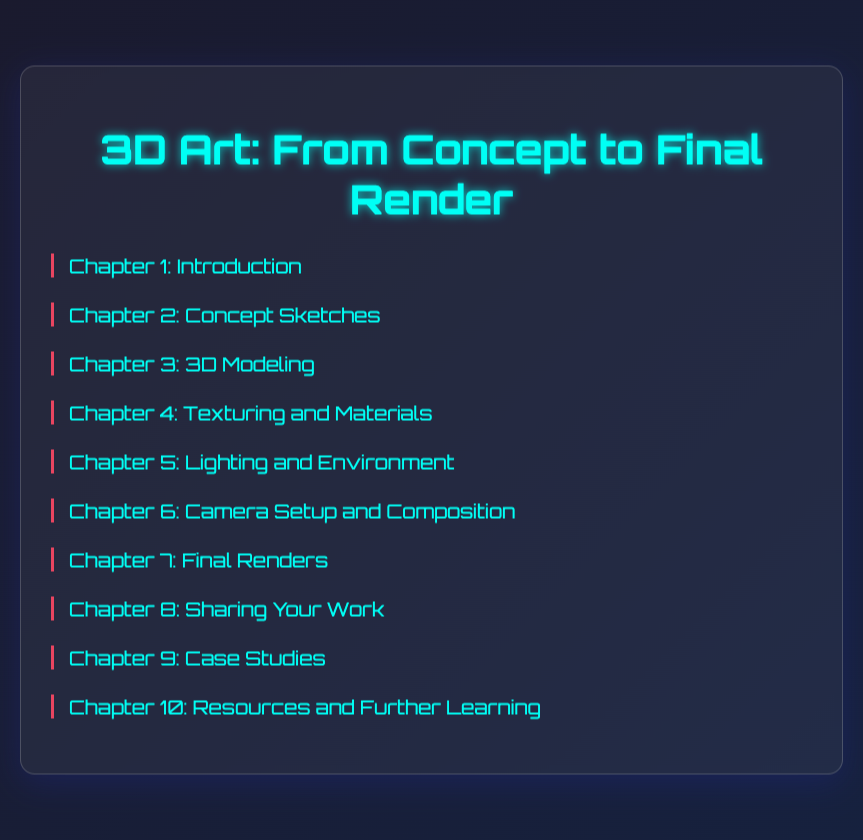What is the title of Chapter 4? Chapter 4 is referenced in the Table of Contents with the title "Texturing and Materials."
Answer: Texturing and Materials How many subtopics does Chapter 3 have? Chapter 3 includes four subtopics listed under it in the Table of Contents.
Answer: 4 What is the focus of Chapter 2? Chapter 2 focuses on "Concept Sketches," including various aspects of sketch creation as outlined in the subtopics.
Answer: Concept Sketches Which chapter discusses social media? The chapter that discusses social media is Chapter 8, titled "Sharing Your Work."
Answer: Sharing Your Work Name one project breakdown included in Chapter 9. One of the project breakdowns mentioned in Chapter 9 is "Cyberpunk Cityscape."
Answer: Cyberpunk Cityscape What is a key takeaway from Chapter 5? Chapter 5 emphasizes the importance of creating realistic lighting techniques for enhancing 3D renders.
Answer: Realistic Lighting Which chapter contains information on rendering settings? Details about rendering settings can be found in Chapter 7, titled "Final Renders."
Answer: Final Renders What type of resources are mentioned in Chapter 10? Chapter 10 covers various resources including tutorials, courses, books, and forums for further learning in 3D art.
Answer: Tutorials and Courses 